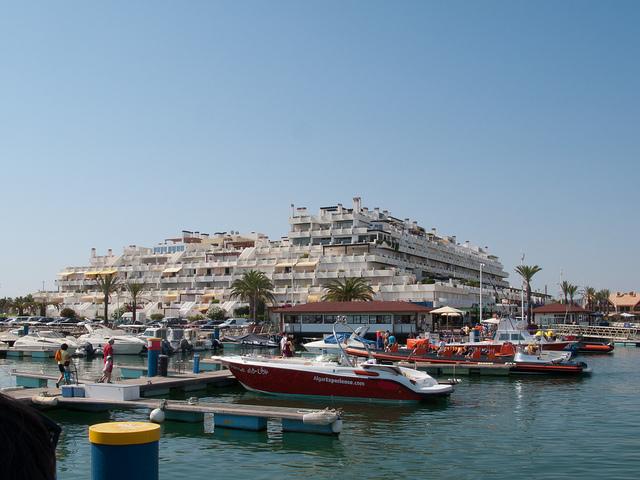Are these container ships?
Concise answer only. No. How many people are standing under the red boat?
Answer briefly. 0. What color is the boat in front?
Answer briefly. Red. What color is the majority of the boats?
Concise answer only. Red. Is the red boats reflection visible in the water?
Quick response, please. Yes. Are there clouds visible?
Be succinct. No. Is it about to rain?
Concise answer only. No. Is there any palm trees in this photo?
Keep it brief. Yes. How many people are on the dock?
Be succinct. 3. What other color is on the yellow boat?
Short answer required. Red. 